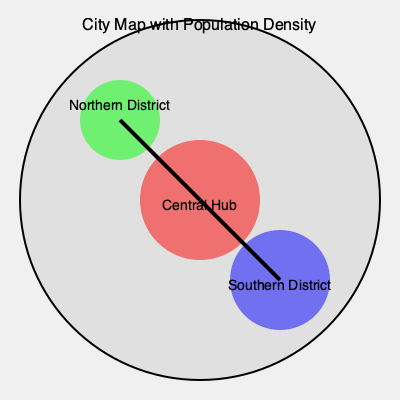Given the city map showing population density, which metro line layout would be most efficient to connect the Central Hub with the Northern and Southern Districts? To determine the most efficient metro line layout, we need to consider several factors:

1. Population density: The size of the colored circles represents the population density in each area.
   - Central Hub (red): Largest population
   - Southern District (blue): Medium population
   - Northern District (green): Smallest population

2. Distance: The length of the lines represents the distance between areas.
   - Central Hub to Northern District: Shorter distance
   - Central Hub to Southern District: Longer distance

3. Efficiency criteria:
   a) Maximize ridership: Connect areas with higher population density
   b) Minimize construction costs: Shorter lines are generally less expensive to build

4. Analysis:
   - A line connecting the Central Hub to the Southern District would serve a larger population but require a longer line.
   - A line connecting the Central Hub to the Northern District would serve a smaller population but require a shorter line.

5. Optimal solution:
   The most efficient layout would be to construct both lines, prioritizing them as follows:
   a) First priority: Central Hub to Southern District (higher population, longer distance)
   b) Second priority: Central Hub to Northern District (smaller population, shorter distance)

This layout maximizes ridership by connecting all three populated areas while balancing construction costs by building the shorter line to the Northern District.
Answer: Y-shaped layout: Central Hub to Southern District (primary), Central Hub to Northern District (secondary) 